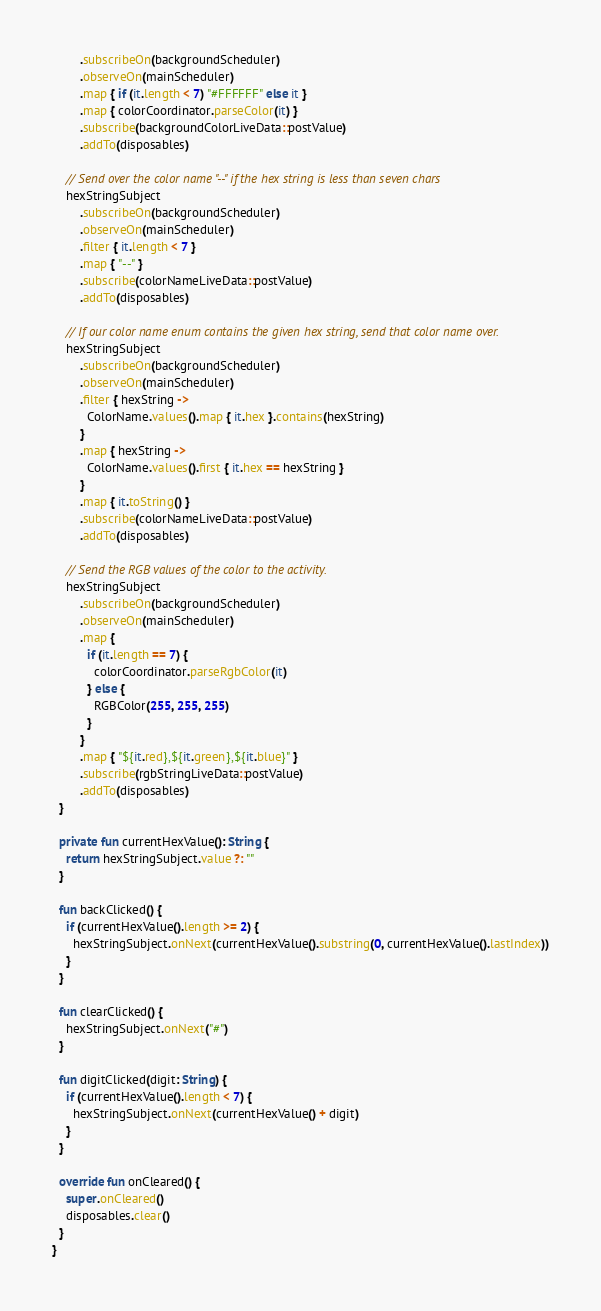Convert code to text. <code><loc_0><loc_0><loc_500><loc_500><_Kotlin_>        .subscribeOn(backgroundScheduler)
        .observeOn(mainScheduler)
        .map { if (it.length < 7) "#FFFFFF" else it }
        .map { colorCoordinator.parseColor(it) }
        .subscribe(backgroundColorLiveData::postValue)
        .addTo(disposables)

    // Send over the color name "--" if the hex string is less than seven chars
    hexStringSubject
        .subscribeOn(backgroundScheduler)
        .observeOn(mainScheduler)
        .filter { it.length < 7 }
        .map { "--" }
        .subscribe(colorNameLiveData::postValue)
        .addTo(disposables)

    // If our color name enum contains the given hex string, send that color name over.
    hexStringSubject
        .subscribeOn(backgroundScheduler)
        .observeOn(mainScheduler)
        .filter { hexString ->
          ColorName.values().map { it.hex }.contains(hexString)
        }
        .map { hexString ->
          ColorName.values().first { it.hex == hexString }
        }
        .map { it.toString() }
        .subscribe(colorNameLiveData::postValue)
        .addTo(disposables)

    // Send the RGB values of the color to the activity.
    hexStringSubject
        .subscribeOn(backgroundScheduler)
        .observeOn(mainScheduler)
        .map {
          if (it.length == 7) {
            colorCoordinator.parseRgbColor(it)
          } else {
            RGBColor(255, 255, 255)
          }
        }
        .map { "${it.red},${it.green},${it.blue}" }
        .subscribe(rgbStringLiveData::postValue)
        .addTo(disposables)
  }

  private fun currentHexValue(): String {
    return hexStringSubject.value ?: ""
  }

  fun backClicked() {
    if (currentHexValue().length >= 2) {
      hexStringSubject.onNext(currentHexValue().substring(0, currentHexValue().lastIndex))
    }
  }

  fun clearClicked() {
    hexStringSubject.onNext("#")
  }

  fun digitClicked(digit: String) {
    if (currentHexValue().length < 7) {
      hexStringSubject.onNext(currentHexValue() + digit)
    }
  }

  override fun onCleared() {
    super.onCleared()
    disposables.clear()
  }
}
</code> 